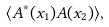Convert formula to latex. <formula><loc_0><loc_0><loc_500><loc_500>\langle A ^ { * } ( x _ { 1 } ) A ( x _ { 2 } ) \rangle ,</formula> 